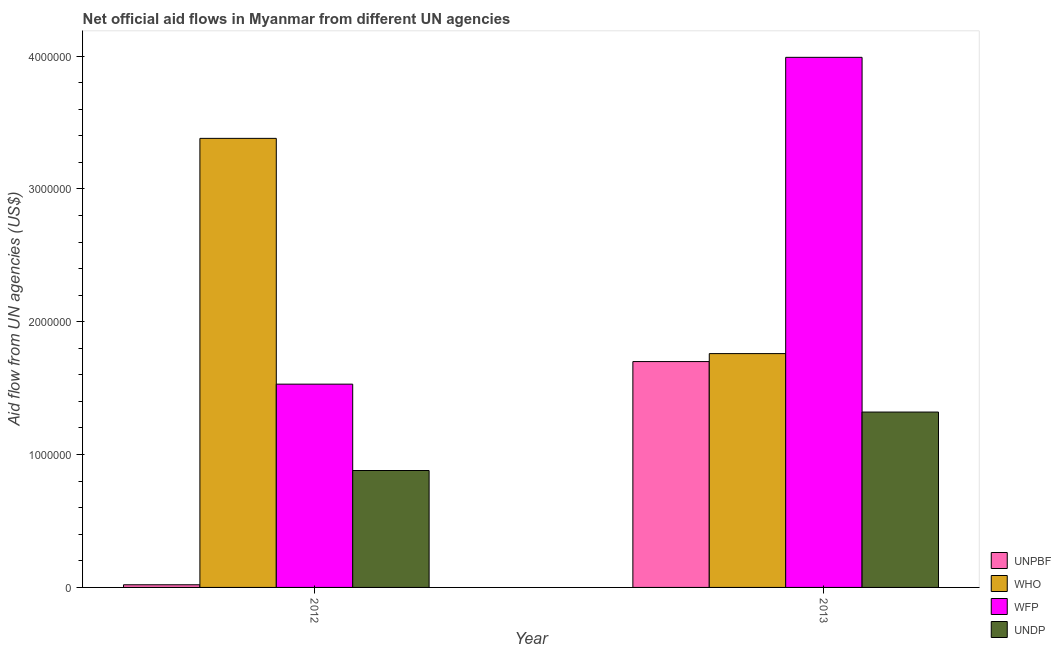Are the number of bars on each tick of the X-axis equal?
Keep it short and to the point. Yes. How many bars are there on the 1st tick from the left?
Ensure brevity in your answer.  4. How many bars are there on the 1st tick from the right?
Offer a terse response. 4. What is the amount of aid given by undp in 2012?
Provide a succinct answer. 8.80e+05. Across all years, what is the maximum amount of aid given by undp?
Make the answer very short. 1.32e+06. Across all years, what is the minimum amount of aid given by unpbf?
Offer a very short reply. 2.00e+04. In which year was the amount of aid given by undp maximum?
Make the answer very short. 2013. What is the total amount of aid given by who in the graph?
Make the answer very short. 5.14e+06. What is the difference between the amount of aid given by unpbf in 2012 and that in 2013?
Your answer should be compact. -1.68e+06. What is the difference between the amount of aid given by who in 2012 and the amount of aid given by undp in 2013?
Keep it short and to the point. 1.62e+06. What is the average amount of aid given by unpbf per year?
Offer a very short reply. 8.60e+05. In the year 2012, what is the difference between the amount of aid given by wfp and amount of aid given by who?
Offer a terse response. 0. What is the ratio of the amount of aid given by wfp in 2012 to that in 2013?
Your response must be concise. 0.38. Is the amount of aid given by who in 2012 less than that in 2013?
Give a very brief answer. No. In how many years, is the amount of aid given by undp greater than the average amount of aid given by undp taken over all years?
Make the answer very short. 1. Is it the case that in every year, the sum of the amount of aid given by undp and amount of aid given by who is greater than the sum of amount of aid given by unpbf and amount of aid given by wfp?
Keep it short and to the point. No. What does the 3rd bar from the left in 2013 represents?
Your answer should be compact. WFP. What does the 4th bar from the right in 2012 represents?
Provide a short and direct response. UNPBF. Is it the case that in every year, the sum of the amount of aid given by unpbf and amount of aid given by who is greater than the amount of aid given by wfp?
Offer a very short reply. No. How many bars are there?
Make the answer very short. 8. Are all the bars in the graph horizontal?
Give a very brief answer. No. How many legend labels are there?
Ensure brevity in your answer.  4. How are the legend labels stacked?
Keep it short and to the point. Vertical. What is the title of the graph?
Keep it short and to the point. Net official aid flows in Myanmar from different UN agencies. What is the label or title of the X-axis?
Your answer should be compact. Year. What is the label or title of the Y-axis?
Ensure brevity in your answer.  Aid flow from UN agencies (US$). What is the Aid flow from UN agencies (US$) of WHO in 2012?
Offer a terse response. 3.38e+06. What is the Aid flow from UN agencies (US$) of WFP in 2012?
Your answer should be compact. 1.53e+06. What is the Aid flow from UN agencies (US$) of UNDP in 2012?
Your answer should be compact. 8.80e+05. What is the Aid flow from UN agencies (US$) in UNPBF in 2013?
Provide a short and direct response. 1.70e+06. What is the Aid flow from UN agencies (US$) of WHO in 2013?
Make the answer very short. 1.76e+06. What is the Aid flow from UN agencies (US$) in WFP in 2013?
Provide a succinct answer. 3.99e+06. What is the Aid flow from UN agencies (US$) of UNDP in 2013?
Make the answer very short. 1.32e+06. Across all years, what is the maximum Aid flow from UN agencies (US$) in UNPBF?
Provide a succinct answer. 1.70e+06. Across all years, what is the maximum Aid flow from UN agencies (US$) in WHO?
Your answer should be compact. 3.38e+06. Across all years, what is the maximum Aid flow from UN agencies (US$) in WFP?
Keep it short and to the point. 3.99e+06. Across all years, what is the maximum Aid flow from UN agencies (US$) of UNDP?
Keep it short and to the point. 1.32e+06. Across all years, what is the minimum Aid flow from UN agencies (US$) in WHO?
Your answer should be very brief. 1.76e+06. Across all years, what is the minimum Aid flow from UN agencies (US$) in WFP?
Offer a very short reply. 1.53e+06. Across all years, what is the minimum Aid flow from UN agencies (US$) of UNDP?
Keep it short and to the point. 8.80e+05. What is the total Aid flow from UN agencies (US$) of UNPBF in the graph?
Offer a terse response. 1.72e+06. What is the total Aid flow from UN agencies (US$) in WHO in the graph?
Give a very brief answer. 5.14e+06. What is the total Aid flow from UN agencies (US$) in WFP in the graph?
Your response must be concise. 5.52e+06. What is the total Aid flow from UN agencies (US$) of UNDP in the graph?
Your answer should be very brief. 2.20e+06. What is the difference between the Aid flow from UN agencies (US$) in UNPBF in 2012 and that in 2013?
Offer a very short reply. -1.68e+06. What is the difference between the Aid flow from UN agencies (US$) in WHO in 2012 and that in 2013?
Keep it short and to the point. 1.62e+06. What is the difference between the Aid flow from UN agencies (US$) in WFP in 2012 and that in 2013?
Offer a terse response. -2.46e+06. What is the difference between the Aid flow from UN agencies (US$) of UNDP in 2012 and that in 2013?
Your answer should be compact. -4.40e+05. What is the difference between the Aid flow from UN agencies (US$) in UNPBF in 2012 and the Aid flow from UN agencies (US$) in WHO in 2013?
Your response must be concise. -1.74e+06. What is the difference between the Aid flow from UN agencies (US$) of UNPBF in 2012 and the Aid flow from UN agencies (US$) of WFP in 2013?
Make the answer very short. -3.97e+06. What is the difference between the Aid flow from UN agencies (US$) in UNPBF in 2012 and the Aid flow from UN agencies (US$) in UNDP in 2013?
Offer a terse response. -1.30e+06. What is the difference between the Aid flow from UN agencies (US$) in WHO in 2012 and the Aid flow from UN agencies (US$) in WFP in 2013?
Your answer should be compact. -6.10e+05. What is the difference between the Aid flow from UN agencies (US$) in WHO in 2012 and the Aid flow from UN agencies (US$) in UNDP in 2013?
Provide a short and direct response. 2.06e+06. What is the difference between the Aid flow from UN agencies (US$) in WFP in 2012 and the Aid flow from UN agencies (US$) in UNDP in 2013?
Your response must be concise. 2.10e+05. What is the average Aid flow from UN agencies (US$) of UNPBF per year?
Offer a terse response. 8.60e+05. What is the average Aid flow from UN agencies (US$) in WHO per year?
Your answer should be very brief. 2.57e+06. What is the average Aid flow from UN agencies (US$) of WFP per year?
Your response must be concise. 2.76e+06. What is the average Aid flow from UN agencies (US$) of UNDP per year?
Your answer should be very brief. 1.10e+06. In the year 2012, what is the difference between the Aid flow from UN agencies (US$) of UNPBF and Aid flow from UN agencies (US$) of WHO?
Provide a succinct answer. -3.36e+06. In the year 2012, what is the difference between the Aid flow from UN agencies (US$) of UNPBF and Aid flow from UN agencies (US$) of WFP?
Ensure brevity in your answer.  -1.51e+06. In the year 2012, what is the difference between the Aid flow from UN agencies (US$) in UNPBF and Aid flow from UN agencies (US$) in UNDP?
Your response must be concise. -8.60e+05. In the year 2012, what is the difference between the Aid flow from UN agencies (US$) in WHO and Aid flow from UN agencies (US$) in WFP?
Provide a succinct answer. 1.85e+06. In the year 2012, what is the difference between the Aid flow from UN agencies (US$) of WHO and Aid flow from UN agencies (US$) of UNDP?
Your answer should be compact. 2.50e+06. In the year 2012, what is the difference between the Aid flow from UN agencies (US$) of WFP and Aid flow from UN agencies (US$) of UNDP?
Give a very brief answer. 6.50e+05. In the year 2013, what is the difference between the Aid flow from UN agencies (US$) in UNPBF and Aid flow from UN agencies (US$) in WFP?
Give a very brief answer. -2.29e+06. In the year 2013, what is the difference between the Aid flow from UN agencies (US$) of WHO and Aid flow from UN agencies (US$) of WFP?
Give a very brief answer. -2.23e+06. In the year 2013, what is the difference between the Aid flow from UN agencies (US$) of WFP and Aid flow from UN agencies (US$) of UNDP?
Ensure brevity in your answer.  2.67e+06. What is the ratio of the Aid flow from UN agencies (US$) of UNPBF in 2012 to that in 2013?
Provide a succinct answer. 0.01. What is the ratio of the Aid flow from UN agencies (US$) of WHO in 2012 to that in 2013?
Make the answer very short. 1.92. What is the ratio of the Aid flow from UN agencies (US$) in WFP in 2012 to that in 2013?
Your answer should be compact. 0.38. What is the ratio of the Aid flow from UN agencies (US$) of UNDP in 2012 to that in 2013?
Provide a succinct answer. 0.67. What is the difference between the highest and the second highest Aid flow from UN agencies (US$) in UNPBF?
Make the answer very short. 1.68e+06. What is the difference between the highest and the second highest Aid flow from UN agencies (US$) of WHO?
Your response must be concise. 1.62e+06. What is the difference between the highest and the second highest Aid flow from UN agencies (US$) of WFP?
Make the answer very short. 2.46e+06. What is the difference between the highest and the lowest Aid flow from UN agencies (US$) of UNPBF?
Offer a very short reply. 1.68e+06. What is the difference between the highest and the lowest Aid flow from UN agencies (US$) of WHO?
Make the answer very short. 1.62e+06. What is the difference between the highest and the lowest Aid flow from UN agencies (US$) in WFP?
Keep it short and to the point. 2.46e+06. 